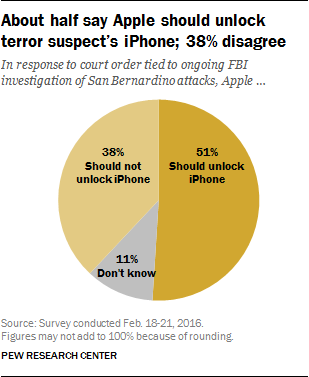Why might 38% of the people disagree with unlocking the iPhone? Those who disagree with unlocking the iPhone might do so because of concerns about privacy and the precedent it could set. They may believe in the importance of protecting personal data and are wary of giving authorities the means to bypass security features, potentially making personal information vulnerable. 